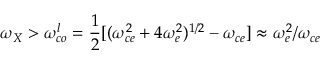<formula> <loc_0><loc_0><loc_500><loc_500>\omega _ { X } > \omega _ { c o } ^ { l } = \frac { 1 } { 2 } [ ( \omega _ { c e } ^ { 2 } + 4 \omega _ { e } ^ { 2 } ) ^ { 1 / 2 } - \omega _ { c e } ] \approx \omega _ { e } ^ { 2 } / \omega _ { c e }</formula> 